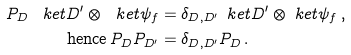Convert formula to latex. <formula><loc_0><loc_0><loc_500><loc_500>P _ { D } \, \ k e t { D ^ { \prime } } \otimes \ k e t { \psi _ { f } } & = \delta _ { D , D ^ { \prime } } \, \ k e t { D ^ { \prime } } \otimes \ k e t { \psi _ { f } } \, , \\ \text {hence} \, P _ { D } P _ { D ^ { \prime } } & = \delta _ { D , D ^ { \prime } } P _ { D } \, .</formula> 